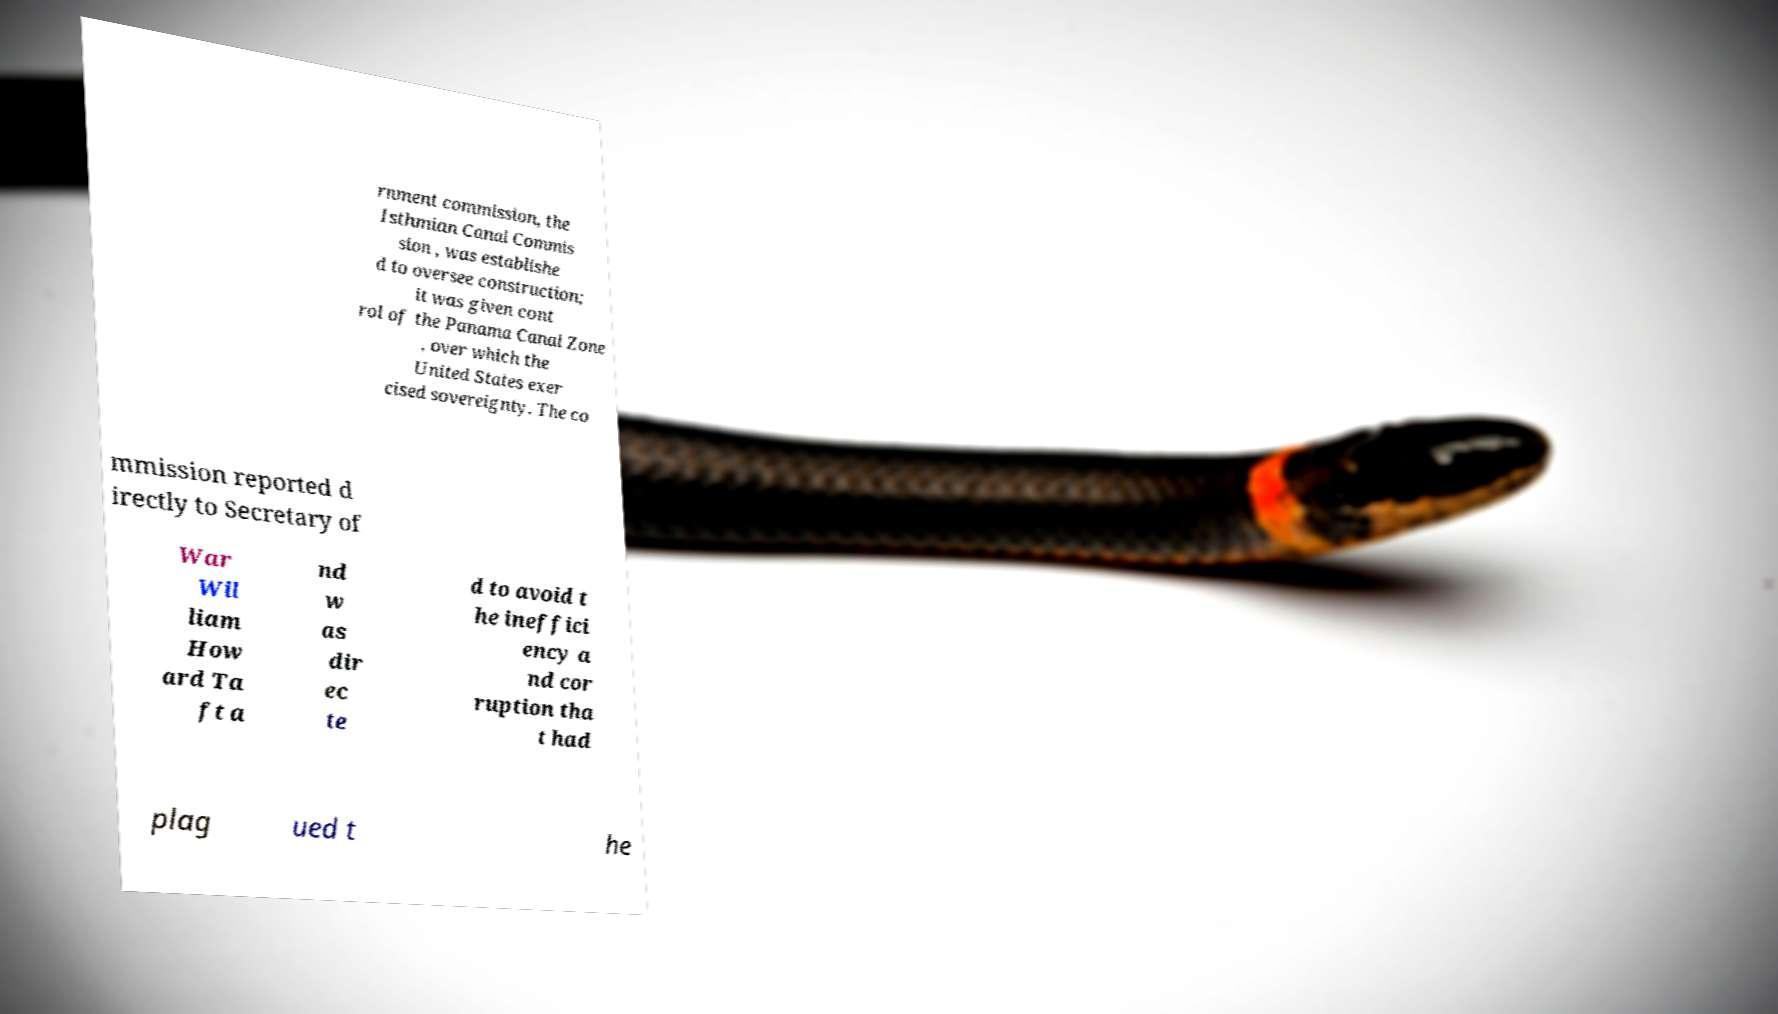Please read and relay the text visible in this image. What does it say? rnment commission, the Isthmian Canal Commis sion , was establishe d to oversee construction; it was given cont rol of the Panama Canal Zone , over which the United States exer cised sovereignty. The co mmission reported d irectly to Secretary of War Wil liam How ard Ta ft a nd w as dir ec te d to avoid t he ineffici ency a nd cor ruption tha t had plag ued t he 